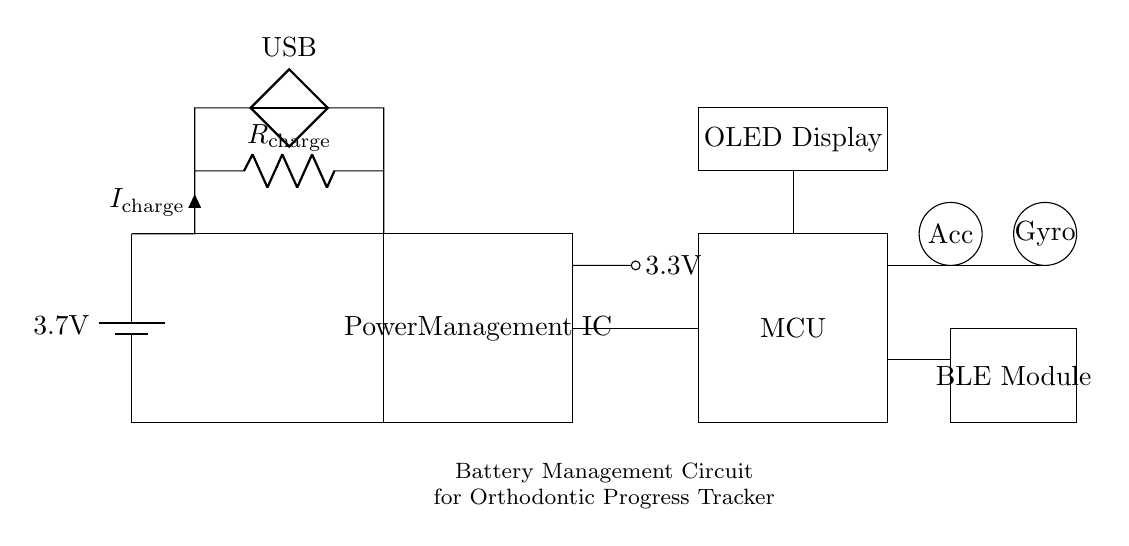What is the power supply voltage of the battery? The battery is labeled with a voltage of 3.7 volts, indicating the potential difference it provides to the circuit.
Answer: 3.7 volts What is the type of display used in the circuit? The circuit diagram shows a rectangle labeled "OLED Display," indicating that this is the type of display used in the device.
Answer: OLED Display Which component is responsible for managing power in the circuit? The rectangle labeled "Power Management IC" signifies that this component controls the power distribution to other parts of the circuit.
Answer: Power Management IC What is the current label in the charging circuit? The charging circuit has a label given as "I charge," indicating the current flowing into the battery during charging.
Answer: I charge How is the information from sensors transmitted in this circuit? The circuit shows a labeled "BLE Module," which implies that the sensors' data is transmitted using Bluetooth Low Energy technology.
Answer: BLE Module What does the acronym "MCU" stand for in the circuit? The rectangle labeled "MCU" refers to "Microcontroller Unit," which is a key component in controlling the overall operations of the wearable device.
Answer: Microcontroller Unit What is the purpose of the charging resistor in the circuit? The resistor labeled "R charge" is used to limit the current flowing to the battery during charging, preventing damage from excessive current.
Answer: Limit current 